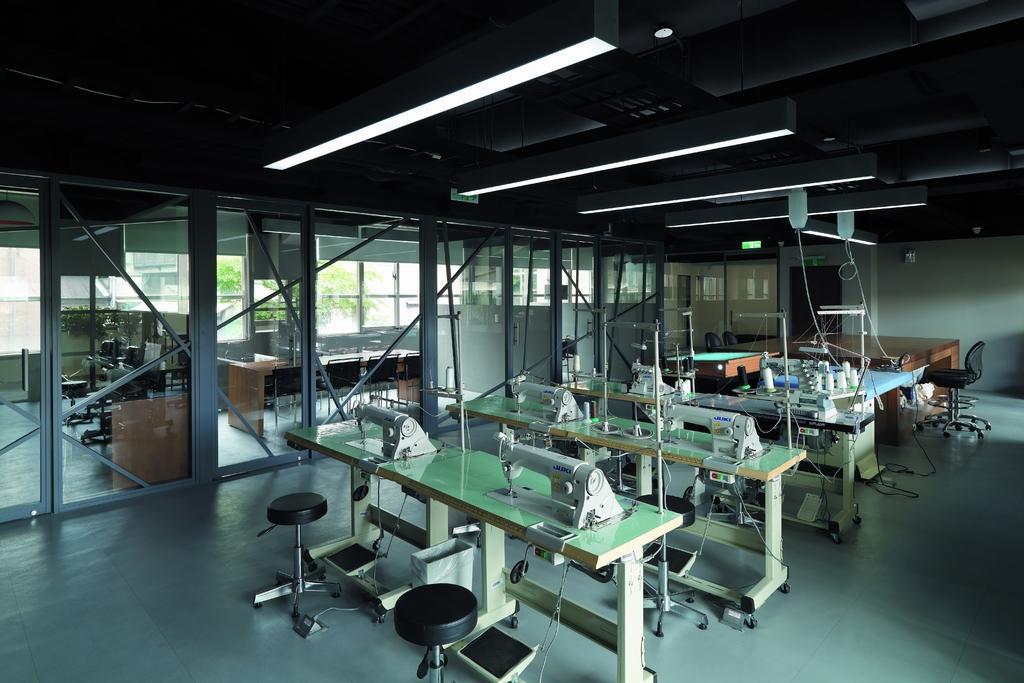Can you describe this image briefly? In this picture there is a room in which many number of tailoring machines were installed. There is a chair and table in the other side of the room. There are doors with glasses. Outside of the room there are tables and chairs. In the background we can observe trees. In the room there are lights attached to the ceiling. 